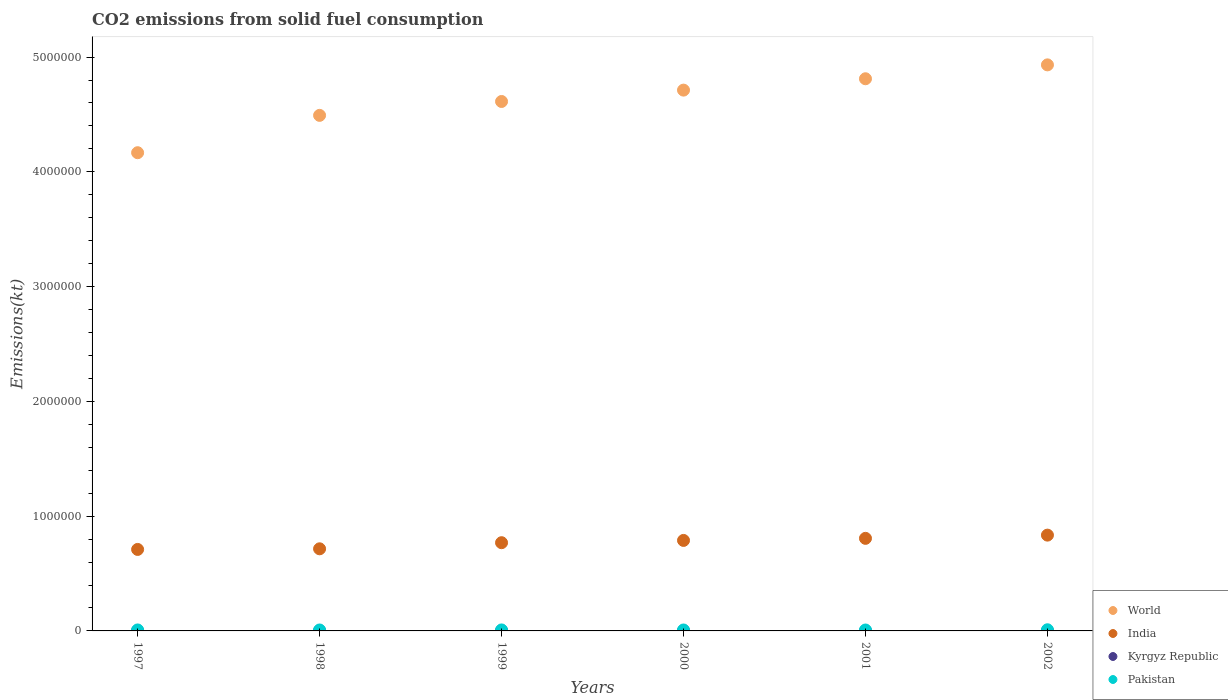What is the amount of CO2 emitted in World in 2000?
Your answer should be very brief. 4.71e+06. Across all years, what is the maximum amount of CO2 emitted in Pakistan?
Make the answer very short. 1.01e+04. Across all years, what is the minimum amount of CO2 emitted in Pakistan?
Your response must be concise. 8049.06. What is the total amount of CO2 emitted in India in the graph?
Offer a very short reply. 4.62e+06. What is the difference between the amount of CO2 emitted in Kyrgyz Republic in 1998 and that in 2000?
Offer a terse response. 51.34. What is the difference between the amount of CO2 emitted in Pakistan in 2000 and the amount of CO2 emitted in World in 2001?
Your answer should be compact. -4.80e+06. What is the average amount of CO2 emitted in World per year?
Offer a very short reply. 4.62e+06. In the year 1999, what is the difference between the amount of CO2 emitted in Pakistan and amount of CO2 emitted in World?
Keep it short and to the point. -4.60e+06. In how many years, is the amount of CO2 emitted in Pakistan greater than 4800000 kt?
Provide a succinct answer. 0. What is the ratio of the amount of CO2 emitted in Kyrgyz Republic in 2000 to that in 2001?
Keep it short and to the point. 1.58. Is the amount of CO2 emitted in Pakistan in 1997 less than that in 2001?
Your answer should be very brief. No. Is the difference between the amount of CO2 emitted in Pakistan in 1998 and 2001 greater than the difference between the amount of CO2 emitted in World in 1998 and 2001?
Make the answer very short. Yes. What is the difference between the highest and the second highest amount of CO2 emitted in India?
Give a very brief answer. 2.81e+04. What is the difference between the highest and the lowest amount of CO2 emitted in World?
Offer a terse response. 7.65e+05. In how many years, is the amount of CO2 emitted in Kyrgyz Republic greater than the average amount of CO2 emitted in Kyrgyz Republic taken over all years?
Provide a succinct answer. 5. Is it the case that in every year, the sum of the amount of CO2 emitted in World and amount of CO2 emitted in Kyrgyz Republic  is greater than the sum of amount of CO2 emitted in India and amount of CO2 emitted in Pakistan?
Your answer should be very brief. No. Does the amount of CO2 emitted in World monotonically increase over the years?
Your answer should be compact. Yes. Is the amount of CO2 emitted in Pakistan strictly greater than the amount of CO2 emitted in India over the years?
Provide a short and direct response. No. How many dotlines are there?
Keep it short and to the point. 4. What is the difference between two consecutive major ticks on the Y-axis?
Give a very brief answer. 1.00e+06. Are the values on the major ticks of Y-axis written in scientific E-notation?
Offer a terse response. No. Does the graph contain any zero values?
Ensure brevity in your answer.  No. Does the graph contain grids?
Your response must be concise. No. How many legend labels are there?
Your response must be concise. 4. How are the legend labels stacked?
Your answer should be very brief. Vertical. What is the title of the graph?
Your answer should be very brief. CO2 emissions from solid fuel consumption. Does "Sub-Saharan Africa (all income levels)" appear as one of the legend labels in the graph?
Offer a very short reply. No. What is the label or title of the Y-axis?
Provide a short and direct response. Emissions(kt). What is the Emissions(kt) in World in 1997?
Your response must be concise. 4.17e+06. What is the Emissions(kt) of India in 1997?
Offer a terse response. 7.10e+05. What is the Emissions(kt) of Kyrgyz Republic in 1997?
Offer a terse response. 1815.16. What is the Emissions(kt) in Pakistan in 1997?
Your answer should be very brief. 8580.78. What is the Emissions(kt) of World in 1998?
Your answer should be compact. 4.49e+06. What is the Emissions(kt) of India in 1998?
Provide a short and direct response. 7.15e+05. What is the Emissions(kt) in Kyrgyz Republic in 1998?
Your answer should be very brief. 1811.5. What is the Emissions(kt) of Pakistan in 1998?
Make the answer very short. 8188.41. What is the Emissions(kt) in World in 1999?
Provide a succinct answer. 4.61e+06. What is the Emissions(kt) in India in 1999?
Ensure brevity in your answer.  7.69e+05. What is the Emissions(kt) in Kyrgyz Republic in 1999?
Ensure brevity in your answer.  1807.83. What is the Emissions(kt) in Pakistan in 1999?
Provide a short and direct response. 8599.11. What is the Emissions(kt) in World in 2000?
Your answer should be compact. 4.71e+06. What is the Emissions(kt) in India in 2000?
Your response must be concise. 7.89e+05. What is the Emissions(kt) of Kyrgyz Republic in 2000?
Offer a very short reply. 1760.16. What is the Emissions(kt) in Pakistan in 2000?
Provide a succinct answer. 8195.75. What is the Emissions(kt) in World in 2001?
Provide a short and direct response. 4.81e+06. What is the Emissions(kt) of India in 2001?
Provide a short and direct response. 8.07e+05. What is the Emissions(kt) of Kyrgyz Republic in 2001?
Give a very brief answer. 1114.77. What is the Emissions(kt) in Pakistan in 2001?
Your answer should be compact. 8049.06. What is the Emissions(kt) of World in 2002?
Keep it short and to the point. 4.93e+06. What is the Emissions(kt) of India in 2002?
Give a very brief answer. 8.35e+05. What is the Emissions(kt) of Kyrgyz Republic in 2002?
Ensure brevity in your answer.  1877.5. What is the Emissions(kt) of Pakistan in 2002?
Your answer should be very brief. 1.01e+04. Across all years, what is the maximum Emissions(kt) in World?
Make the answer very short. 4.93e+06. Across all years, what is the maximum Emissions(kt) of India?
Your answer should be very brief. 8.35e+05. Across all years, what is the maximum Emissions(kt) of Kyrgyz Republic?
Give a very brief answer. 1877.5. Across all years, what is the maximum Emissions(kt) of Pakistan?
Keep it short and to the point. 1.01e+04. Across all years, what is the minimum Emissions(kt) of World?
Give a very brief answer. 4.17e+06. Across all years, what is the minimum Emissions(kt) of India?
Make the answer very short. 7.10e+05. Across all years, what is the minimum Emissions(kt) in Kyrgyz Republic?
Provide a short and direct response. 1114.77. Across all years, what is the minimum Emissions(kt) in Pakistan?
Provide a succinct answer. 8049.06. What is the total Emissions(kt) in World in the graph?
Offer a terse response. 2.77e+07. What is the total Emissions(kt) of India in the graph?
Give a very brief answer. 4.62e+06. What is the total Emissions(kt) of Kyrgyz Republic in the graph?
Provide a short and direct response. 1.02e+04. What is the total Emissions(kt) of Pakistan in the graph?
Offer a very short reply. 5.17e+04. What is the difference between the Emissions(kt) in World in 1997 and that in 1998?
Your response must be concise. -3.25e+05. What is the difference between the Emissions(kt) of India in 1997 and that in 1998?
Your response must be concise. -5460.16. What is the difference between the Emissions(kt) in Kyrgyz Republic in 1997 and that in 1998?
Make the answer very short. 3.67. What is the difference between the Emissions(kt) in Pakistan in 1997 and that in 1998?
Make the answer very short. 392.37. What is the difference between the Emissions(kt) in World in 1997 and that in 1999?
Your response must be concise. -4.46e+05. What is the difference between the Emissions(kt) of India in 1997 and that in 1999?
Offer a terse response. -5.87e+04. What is the difference between the Emissions(kt) of Kyrgyz Republic in 1997 and that in 1999?
Keep it short and to the point. 7.33. What is the difference between the Emissions(kt) of Pakistan in 1997 and that in 1999?
Offer a terse response. -18.34. What is the difference between the Emissions(kt) of World in 1997 and that in 2000?
Offer a very short reply. -5.45e+05. What is the difference between the Emissions(kt) of India in 1997 and that in 2000?
Your answer should be very brief. -7.85e+04. What is the difference between the Emissions(kt) of Kyrgyz Republic in 1997 and that in 2000?
Give a very brief answer. 55.01. What is the difference between the Emissions(kt) in Pakistan in 1997 and that in 2000?
Offer a very short reply. 385.04. What is the difference between the Emissions(kt) in World in 1997 and that in 2001?
Your response must be concise. -6.44e+05. What is the difference between the Emissions(kt) in India in 1997 and that in 2001?
Give a very brief answer. -9.66e+04. What is the difference between the Emissions(kt) in Kyrgyz Republic in 1997 and that in 2001?
Ensure brevity in your answer.  700.4. What is the difference between the Emissions(kt) in Pakistan in 1997 and that in 2001?
Keep it short and to the point. 531.72. What is the difference between the Emissions(kt) of World in 1997 and that in 2002?
Make the answer very short. -7.65e+05. What is the difference between the Emissions(kt) of India in 1997 and that in 2002?
Keep it short and to the point. -1.25e+05. What is the difference between the Emissions(kt) in Kyrgyz Republic in 1997 and that in 2002?
Offer a very short reply. -62.34. What is the difference between the Emissions(kt) in Pakistan in 1997 and that in 2002?
Make the answer very short. -1507.14. What is the difference between the Emissions(kt) of World in 1998 and that in 1999?
Make the answer very short. -1.21e+05. What is the difference between the Emissions(kt) in India in 1998 and that in 1999?
Your response must be concise. -5.32e+04. What is the difference between the Emissions(kt) in Kyrgyz Republic in 1998 and that in 1999?
Your answer should be compact. 3.67. What is the difference between the Emissions(kt) in Pakistan in 1998 and that in 1999?
Provide a short and direct response. -410.7. What is the difference between the Emissions(kt) of World in 1998 and that in 2000?
Your answer should be very brief. -2.20e+05. What is the difference between the Emissions(kt) in India in 1998 and that in 2000?
Offer a very short reply. -7.30e+04. What is the difference between the Emissions(kt) of Kyrgyz Republic in 1998 and that in 2000?
Your response must be concise. 51.34. What is the difference between the Emissions(kt) of Pakistan in 1998 and that in 2000?
Ensure brevity in your answer.  -7.33. What is the difference between the Emissions(kt) in World in 1998 and that in 2001?
Provide a short and direct response. -3.19e+05. What is the difference between the Emissions(kt) of India in 1998 and that in 2001?
Keep it short and to the point. -9.11e+04. What is the difference between the Emissions(kt) in Kyrgyz Republic in 1998 and that in 2001?
Make the answer very short. 696.73. What is the difference between the Emissions(kt) in Pakistan in 1998 and that in 2001?
Ensure brevity in your answer.  139.35. What is the difference between the Emissions(kt) in World in 1998 and that in 2002?
Your answer should be very brief. -4.40e+05. What is the difference between the Emissions(kt) in India in 1998 and that in 2002?
Your answer should be compact. -1.19e+05. What is the difference between the Emissions(kt) of Kyrgyz Republic in 1998 and that in 2002?
Your answer should be very brief. -66.01. What is the difference between the Emissions(kt) in Pakistan in 1998 and that in 2002?
Your response must be concise. -1899.51. What is the difference between the Emissions(kt) of World in 1999 and that in 2000?
Your response must be concise. -9.90e+04. What is the difference between the Emissions(kt) of India in 1999 and that in 2000?
Keep it short and to the point. -1.98e+04. What is the difference between the Emissions(kt) in Kyrgyz Republic in 1999 and that in 2000?
Offer a terse response. 47.67. What is the difference between the Emissions(kt) in Pakistan in 1999 and that in 2000?
Your response must be concise. 403.37. What is the difference between the Emissions(kt) of World in 1999 and that in 2001?
Your answer should be compact. -1.98e+05. What is the difference between the Emissions(kt) in India in 1999 and that in 2001?
Ensure brevity in your answer.  -3.79e+04. What is the difference between the Emissions(kt) in Kyrgyz Republic in 1999 and that in 2001?
Offer a very short reply. 693.06. What is the difference between the Emissions(kt) of Pakistan in 1999 and that in 2001?
Your response must be concise. 550.05. What is the difference between the Emissions(kt) of World in 1999 and that in 2002?
Your answer should be compact. -3.19e+05. What is the difference between the Emissions(kt) of India in 1999 and that in 2002?
Ensure brevity in your answer.  -6.60e+04. What is the difference between the Emissions(kt) of Kyrgyz Republic in 1999 and that in 2002?
Your response must be concise. -69.67. What is the difference between the Emissions(kt) in Pakistan in 1999 and that in 2002?
Your answer should be very brief. -1488.8. What is the difference between the Emissions(kt) in World in 2000 and that in 2001?
Your answer should be very brief. -9.90e+04. What is the difference between the Emissions(kt) in India in 2000 and that in 2001?
Provide a short and direct response. -1.81e+04. What is the difference between the Emissions(kt) in Kyrgyz Republic in 2000 and that in 2001?
Your answer should be very brief. 645.39. What is the difference between the Emissions(kt) of Pakistan in 2000 and that in 2001?
Provide a short and direct response. 146.68. What is the difference between the Emissions(kt) of World in 2000 and that in 2002?
Offer a very short reply. -2.20e+05. What is the difference between the Emissions(kt) of India in 2000 and that in 2002?
Provide a short and direct response. -4.62e+04. What is the difference between the Emissions(kt) in Kyrgyz Republic in 2000 and that in 2002?
Your answer should be very brief. -117.34. What is the difference between the Emissions(kt) of Pakistan in 2000 and that in 2002?
Make the answer very short. -1892.17. What is the difference between the Emissions(kt) of World in 2001 and that in 2002?
Your response must be concise. -1.21e+05. What is the difference between the Emissions(kt) of India in 2001 and that in 2002?
Your answer should be compact. -2.81e+04. What is the difference between the Emissions(kt) of Kyrgyz Republic in 2001 and that in 2002?
Your answer should be compact. -762.74. What is the difference between the Emissions(kt) of Pakistan in 2001 and that in 2002?
Make the answer very short. -2038.85. What is the difference between the Emissions(kt) in World in 1997 and the Emissions(kt) in India in 1998?
Your answer should be compact. 3.45e+06. What is the difference between the Emissions(kt) of World in 1997 and the Emissions(kt) of Kyrgyz Republic in 1998?
Give a very brief answer. 4.16e+06. What is the difference between the Emissions(kt) in World in 1997 and the Emissions(kt) in Pakistan in 1998?
Give a very brief answer. 4.16e+06. What is the difference between the Emissions(kt) in India in 1997 and the Emissions(kt) in Kyrgyz Republic in 1998?
Your answer should be compact. 7.08e+05. What is the difference between the Emissions(kt) in India in 1997 and the Emissions(kt) in Pakistan in 1998?
Ensure brevity in your answer.  7.02e+05. What is the difference between the Emissions(kt) in Kyrgyz Republic in 1997 and the Emissions(kt) in Pakistan in 1998?
Ensure brevity in your answer.  -6373.25. What is the difference between the Emissions(kt) in World in 1997 and the Emissions(kt) in India in 1999?
Keep it short and to the point. 3.40e+06. What is the difference between the Emissions(kt) of World in 1997 and the Emissions(kt) of Kyrgyz Republic in 1999?
Provide a succinct answer. 4.16e+06. What is the difference between the Emissions(kt) in World in 1997 and the Emissions(kt) in Pakistan in 1999?
Your answer should be very brief. 4.16e+06. What is the difference between the Emissions(kt) in India in 1997 and the Emissions(kt) in Kyrgyz Republic in 1999?
Provide a short and direct response. 7.08e+05. What is the difference between the Emissions(kt) in India in 1997 and the Emissions(kt) in Pakistan in 1999?
Your response must be concise. 7.01e+05. What is the difference between the Emissions(kt) in Kyrgyz Republic in 1997 and the Emissions(kt) in Pakistan in 1999?
Make the answer very short. -6783.95. What is the difference between the Emissions(kt) of World in 1997 and the Emissions(kt) of India in 2000?
Your answer should be compact. 3.38e+06. What is the difference between the Emissions(kt) of World in 1997 and the Emissions(kt) of Kyrgyz Republic in 2000?
Make the answer very short. 4.17e+06. What is the difference between the Emissions(kt) in World in 1997 and the Emissions(kt) in Pakistan in 2000?
Ensure brevity in your answer.  4.16e+06. What is the difference between the Emissions(kt) of India in 1997 and the Emissions(kt) of Kyrgyz Republic in 2000?
Make the answer very short. 7.08e+05. What is the difference between the Emissions(kt) of India in 1997 and the Emissions(kt) of Pakistan in 2000?
Your response must be concise. 7.02e+05. What is the difference between the Emissions(kt) in Kyrgyz Republic in 1997 and the Emissions(kt) in Pakistan in 2000?
Offer a very short reply. -6380.58. What is the difference between the Emissions(kt) of World in 1997 and the Emissions(kt) of India in 2001?
Make the answer very short. 3.36e+06. What is the difference between the Emissions(kt) of World in 1997 and the Emissions(kt) of Kyrgyz Republic in 2001?
Give a very brief answer. 4.17e+06. What is the difference between the Emissions(kt) in World in 1997 and the Emissions(kt) in Pakistan in 2001?
Provide a succinct answer. 4.16e+06. What is the difference between the Emissions(kt) in India in 1997 and the Emissions(kt) in Kyrgyz Republic in 2001?
Your answer should be compact. 7.09e+05. What is the difference between the Emissions(kt) of India in 1997 and the Emissions(kt) of Pakistan in 2001?
Offer a very short reply. 7.02e+05. What is the difference between the Emissions(kt) in Kyrgyz Republic in 1997 and the Emissions(kt) in Pakistan in 2001?
Provide a succinct answer. -6233.9. What is the difference between the Emissions(kt) of World in 1997 and the Emissions(kt) of India in 2002?
Provide a succinct answer. 3.33e+06. What is the difference between the Emissions(kt) in World in 1997 and the Emissions(kt) in Kyrgyz Republic in 2002?
Provide a short and direct response. 4.16e+06. What is the difference between the Emissions(kt) in World in 1997 and the Emissions(kt) in Pakistan in 2002?
Provide a succinct answer. 4.16e+06. What is the difference between the Emissions(kt) in India in 1997 and the Emissions(kt) in Kyrgyz Republic in 2002?
Give a very brief answer. 7.08e+05. What is the difference between the Emissions(kt) of India in 1997 and the Emissions(kt) of Pakistan in 2002?
Provide a succinct answer. 7.00e+05. What is the difference between the Emissions(kt) in Kyrgyz Republic in 1997 and the Emissions(kt) in Pakistan in 2002?
Ensure brevity in your answer.  -8272.75. What is the difference between the Emissions(kt) in World in 1998 and the Emissions(kt) in India in 1999?
Your answer should be very brief. 3.72e+06. What is the difference between the Emissions(kt) of World in 1998 and the Emissions(kt) of Kyrgyz Republic in 1999?
Offer a very short reply. 4.49e+06. What is the difference between the Emissions(kt) of World in 1998 and the Emissions(kt) of Pakistan in 1999?
Provide a succinct answer. 4.48e+06. What is the difference between the Emissions(kt) of India in 1998 and the Emissions(kt) of Kyrgyz Republic in 1999?
Your answer should be compact. 7.14e+05. What is the difference between the Emissions(kt) of India in 1998 and the Emissions(kt) of Pakistan in 1999?
Your response must be concise. 7.07e+05. What is the difference between the Emissions(kt) of Kyrgyz Republic in 1998 and the Emissions(kt) of Pakistan in 1999?
Make the answer very short. -6787.62. What is the difference between the Emissions(kt) of World in 1998 and the Emissions(kt) of India in 2000?
Provide a short and direct response. 3.70e+06. What is the difference between the Emissions(kt) of World in 1998 and the Emissions(kt) of Kyrgyz Republic in 2000?
Give a very brief answer. 4.49e+06. What is the difference between the Emissions(kt) in World in 1998 and the Emissions(kt) in Pakistan in 2000?
Provide a short and direct response. 4.48e+06. What is the difference between the Emissions(kt) in India in 1998 and the Emissions(kt) in Kyrgyz Republic in 2000?
Your answer should be very brief. 7.14e+05. What is the difference between the Emissions(kt) in India in 1998 and the Emissions(kt) in Pakistan in 2000?
Offer a terse response. 7.07e+05. What is the difference between the Emissions(kt) of Kyrgyz Republic in 1998 and the Emissions(kt) of Pakistan in 2000?
Your answer should be compact. -6384.25. What is the difference between the Emissions(kt) in World in 1998 and the Emissions(kt) in India in 2001?
Ensure brevity in your answer.  3.69e+06. What is the difference between the Emissions(kt) of World in 1998 and the Emissions(kt) of Kyrgyz Republic in 2001?
Provide a succinct answer. 4.49e+06. What is the difference between the Emissions(kt) in World in 1998 and the Emissions(kt) in Pakistan in 2001?
Offer a very short reply. 4.48e+06. What is the difference between the Emissions(kt) in India in 1998 and the Emissions(kt) in Kyrgyz Republic in 2001?
Provide a short and direct response. 7.14e+05. What is the difference between the Emissions(kt) of India in 1998 and the Emissions(kt) of Pakistan in 2001?
Give a very brief answer. 7.07e+05. What is the difference between the Emissions(kt) of Kyrgyz Republic in 1998 and the Emissions(kt) of Pakistan in 2001?
Make the answer very short. -6237.57. What is the difference between the Emissions(kt) of World in 1998 and the Emissions(kt) of India in 2002?
Your answer should be compact. 3.66e+06. What is the difference between the Emissions(kt) in World in 1998 and the Emissions(kt) in Kyrgyz Republic in 2002?
Offer a very short reply. 4.49e+06. What is the difference between the Emissions(kt) in World in 1998 and the Emissions(kt) in Pakistan in 2002?
Give a very brief answer. 4.48e+06. What is the difference between the Emissions(kt) in India in 1998 and the Emissions(kt) in Kyrgyz Republic in 2002?
Provide a short and direct response. 7.14e+05. What is the difference between the Emissions(kt) of India in 1998 and the Emissions(kt) of Pakistan in 2002?
Provide a short and direct response. 7.05e+05. What is the difference between the Emissions(kt) of Kyrgyz Republic in 1998 and the Emissions(kt) of Pakistan in 2002?
Offer a terse response. -8276.42. What is the difference between the Emissions(kt) in World in 1999 and the Emissions(kt) in India in 2000?
Offer a very short reply. 3.82e+06. What is the difference between the Emissions(kt) of World in 1999 and the Emissions(kt) of Kyrgyz Republic in 2000?
Your answer should be very brief. 4.61e+06. What is the difference between the Emissions(kt) in World in 1999 and the Emissions(kt) in Pakistan in 2000?
Give a very brief answer. 4.60e+06. What is the difference between the Emissions(kt) in India in 1999 and the Emissions(kt) in Kyrgyz Republic in 2000?
Ensure brevity in your answer.  7.67e+05. What is the difference between the Emissions(kt) of India in 1999 and the Emissions(kt) of Pakistan in 2000?
Provide a succinct answer. 7.60e+05. What is the difference between the Emissions(kt) of Kyrgyz Republic in 1999 and the Emissions(kt) of Pakistan in 2000?
Provide a succinct answer. -6387.91. What is the difference between the Emissions(kt) in World in 1999 and the Emissions(kt) in India in 2001?
Provide a succinct answer. 3.81e+06. What is the difference between the Emissions(kt) in World in 1999 and the Emissions(kt) in Kyrgyz Republic in 2001?
Ensure brevity in your answer.  4.61e+06. What is the difference between the Emissions(kt) in World in 1999 and the Emissions(kt) in Pakistan in 2001?
Your response must be concise. 4.61e+06. What is the difference between the Emissions(kt) of India in 1999 and the Emissions(kt) of Kyrgyz Republic in 2001?
Your response must be concise. 7.68e+05. What is the difference between the Emissions(kt) in India in 1999 and the Emissions(kt) in Pakistan in 2001?
Offer a terse response. 7.61e+05. What is the difference between the Emissions(kt) of Kyrgyz Republic in 1999 and the Emissions(kt) of Pakistan in 2001?
Provide a succinct answer. -6241.23. What is the difference between the Emissions(kt) of World in 1999 and the Emissions(kt) of India in 2002?
Make the answer very short. 3.78e+06. What is the difference between the Emissions(kt) in World in 1999 and the Emissions(kt) in Kyrgyz Republic in 2002?
Offer a terse response. 4.61e+06. What is the difference between the Emissions(kt) in World in 1999 and the Emissions(kt) in Pakistan in 2002?
Your response must be concise. 4.60e+06. What is the difference between the Emissions(kt) in India in 1999 and the Emissions(kt) in Kyrgyz Republic in 2002?
Offer a terse response. 7.67e+05. What is the difference between the Emissions(kt) of India in 1999 and the Emissions(kt) of Pakistan in 2002?
Your answer should be very brief. 7.59e+05. What is the difference between the Emissions(kt) of Kyrgyz Republic in 1999 and the Emissions(kt) of Pakistan in 2002?
Your response must be concise. -8280.09. What is the difference between the Emissions(kt) in World in 2000 and the Emissions(kt) in India in 2001?
Give a very brief answer. 3.91e+06. What is the difference between the Emissions(kt) in World in 2000 and the Emissions(kt) in Kyrgyz Republic in 2001?
Provide a succinct answer. 4.71e+06. What is the difference between the Emissions(kt) of World in 2000 and the Emissions(kt) of Pakistan in 2001?
Your answer should be very brief. 4.70e+06. What is the difference between the Emissions(kt) of India in 2000 and the Emissions(kt) of Kyrgyz Republic in 2001?
Offer a terse response. 7.87e+05. What is the difference between the Emissions(kt) of India in 2000 and the Emissions(kt) of Pakistan in 2001?
Provide a short and direct response. 7.80e+05. What is the difference between the Emissions(kt) of Kyrgyz Republic in 2000 and the Emissions(kt) of Pakistan in 2001?
Ensure brevity in your answer.  -6288.9. What is the difference between the Emissions(kt) of World in 2000 and the Emissions(kt) of India in 2002?
Provide a succinct answer. 3.88e+06. What is the difference between the Emissions(kt) of World in 2000 and the Emissions(kt) of Kyrgyz Republic in 2002?
Ensure brevity in your answer.  4.71e+06. What is the difference between the Emissions(kt) of World in 2000 and the Emissions(kt) of Pakistan in 2002?
Give a very brief answer. 4.70e+06. What is the difference between the Emissions(kt) in India in 2000 and the Emissions(kt) in Kyrgyz Republic in 2002?
Ensure brevity in your answer.  7.87e+05. What is the difference between the Emissions(kt) of India in 2000 and the Emissions(kt) of Pakistan in 2002?
Give a very brief answer. 7.78e+05. What is the difference between the Emissions(kt) of Kyrgyz Republic in 2000 and the Emissions(kt) of Pakistan in 2002?
Give a very brief answer. -8327.76. What is the difference between the Emissions(kt) in World in 2001 and the Emissions(kt) in India in 2002?
Your answer should be very brief. 3.98e+06. What is the difference between the Emissions(kt) of World in 2001 and the Emissions(kt) of Kyrgyz Republic in 2002?
Your answer should be compact. 4.81e+06. What is the difference between the Emissions(kt) in World in 2001 and the Emissions(kt) in Pakistan in 2002?
Make the answer very short. 4.80e+06. What is the difference between the Emissions(kt) of India in 2001 and the Emissions(kt) of Kyrgyz Republic in 2002?
Offer a very short reply. 8.05e+05. What is the difference between the Emissions(kt) in India in 2001 and the Emissions(kt) in Pakistan in 2002?
Offer a very short reply. 7.96e+05. What is the difference between the Emissions(kt) in Kyrgyz Republic in 2001 and the Emissions(kt) in Pakistan in 2002?
Offer a very short reply. -8973.15. What is the average Emissions(kt) of World per year?
Give a very brief answer. 4.62e+06. What is the average Emissions(kt) of India per year?
Provide a succinct answer. 7.71e+05. What is the average Emissions(kt) of Kyrgyz Republic per year?
Provide a succinct answer. 1697.82. What is the average Emissions(kt) of Pakistan per year?
Keep it short and to the point. 8616.84. In the year 1997, what is the difference between the Emissions(kt) in World and Emissions(kt) in India?
Offer a terse response. 3.46e+06. In the year 1997, what is the difference between the Emissions(kt) in World and Emissions(kt) in Kyrgyz Republic?
Provide a succinct answer. 4.16e+06. In the year 1997, what is the difference between the Emissions(kt) in World and Emissions(kt) in Pakistan?
Offer a terse response. 4.16e+06. In the year 1997, what is the difference between the Emissions(kt) of India and Emissions(kt) of Kyrgyz Republic?
Provide a short and direct response. 7.08e+05. In the year 1997, what is the difference between the Emissions(kt) of India and Emissions(kt) of Pakistan?
Offer a very short reply. 7.01e+05. In the year 1997, what is the difference between the Emissions(kt) in Kyrgyz Republic and Emissions(kt) in Pakistan?
Your response must be concise. -6765.61. In the year 1998, what is the difference between the Emissions(kt) in World and Emissions(kt) in India?
Provide a succinct answer. 3.78e+06. In the year 1998, what is the difference between the Emissions(kt) in World and Emissions(kt) in Kyrgyz Republic?
Your answer should be very brief. 4.49e+06. In the year 1998, what is the difference between the Emissions(kt) in World and Emissions(kt) in Pakistan?
Provide a succinct answer. 4.48e+06. In the year 1998, what is the difference between the Emissions(kt) of India and Emissions(kt) of Kyrgyz Republic?
Provide a short and direct response. 7.14e+05. In the year 1998, what is the difference between the Emissions(kt) in India and Emissions(kt) in Pakistan?
Make the answer very short. 7.07e+05. In the year 1998, what is the difference between the Emissions(kt) of Kyrgyz Republic and Emissions(kt) of Pakistan?
Your answer should be very brief. -6376.91. In the year 1999, what is the difference between the Emissions(kt) in World and Emissions(kt) in India?
Your response must be concise. 3.84e+06. In the year 1999, what is the difference between the Emissions(kt) of World and Emissions(kt) of Kyrgyz Republic?
Your answer should be very brief. 4.61e+06. In the year 1999, what is the difference between the Emissions(kt) of World and Emissions(kt) of Pakistan?
Your answer should be very brief. 4.60e+06. In the year 1999, what is the difference between the Emissions(kt) in India and Emissions(kt) in Kyrgyz Republic?
Provide a short and direct response. 7.67e+05. In the year 1999, what is the difference between the Emissions(kt) in India and Emissions(kt) in Pakistan?
Keep it short and to the point. 7.60e+05. In the year 1999, what is the difference between the Emissions(kt) of Kyrgyz Republic and Emissions(kt) of Pakistan?
Keep it short and to the point. -6791.28. In the year 2000, what is the difference between the Emissions(kt) of World and Emissions(kt) of India?
Ensure brevity in your answer.  3.92e+06. In the year 2000, what is the difference between the Emissions(kt) of World and Emissions(kt) of Kyrgyz Republic?
Make the answer very short. 4.71e+06. In the year 2000, what is the difference between the Emissions(kt) in World and Emissions(kt) in Pakistan?
Offer a terse response. 4.70e+06. In the year 2000, what is the difference between the Emissions(kt) in India and Emissions(kt) in Kyrgyz Republic?
Provide a short and direct response. 7.87e+05. In the year 2000, what is the difference between the Emissions(kt) in India and Emissions(kt) in Pakistan?
Keep it short and to the point. 7.80e+05. In the year 2000, what is the difference between the Emissions(kt) of Kyrgyz Republic and Emissions(kt) of Pakistan?
Offer a very short reply. -6435.59. In the year 2001, what is the difference between the Emissions(kt) of World and Emissions(kt) of India?
Your response must be concise. 4.00e+06. In the year 2001, what is the difference between the Emissions(kt) of World and Emissions(kt) of Kyrgyz Republic?
Your response must be concise. 4.81e+06. In the year 2001, what is the difference between the Emissions(kt) of World and Emissions(kt) of Pakistan?
Keep it short and to the point. 4.80e+06. In the year 2001, what is the difference between the Emissions(kt) in India and Emissions(kt) in Kyrgyz Republic?
Provide a succinct answer. 8.05e+05. In the year 2001, what is the difference between the Emissions(kt) of India and Emissions(kt) of Pakistan?
Give a very brief answer. 7.99e+05. In the year 2001, what is the difference between the Emissions(kt) of Kyrgyz Republic and Emissions(kt) of Pakistan?
Offer a very short reply. -6934.3. In the year 2002, what is the difference between the Emissions(kt) in World and Emissions(kt) in India?
Provide a short and direct response. 4.10e+06. In the year 2002, what is the difference between the Emissions(kt) in World and Emissions(kt) in Kyrgyz Republic?
Give a very brief answer. 4.93e+06. In the year 2002, what is the difference between the Emissions(kt) of World and Emissions(kt) of Pakistan?
Make the answer very short. 4.92e+06. In the year 2002, what is the difference between the Emissions(kt) of India and Emissions(kt) of Kyrgyz Republic?
Offer a terse response. 8.33e+05. In the year 2002, what is the difference between the Emissions(kt) of India and Emissions(kt) of Pakistan?
Your response must be concise. 8.25e+05. In the year 2002, what is the difference between the Emissions(kt) of Kyrgyz Republic and Emissions(kt) of Pakistan?
Your answer should be compact. -8210.41. What is the ratio of the Emissions(kt) in World in 1997 to that in 1998?
Provide a succinct answer. 0.93. What is the ratio of the Emissions(kt) in India in 1997 to that in 1998?
Keep it short and to the point. 0.99. What is the ratio of the Emissions(kt) in Kyrgyz Republic in 1997 to that in 1998?
Make the answer very short. 1. What is the ratio of the Emissions(kt) of Pakistan in 1997 to that in 1998?
Keep it short and to the point. 1.05. What is the ratio of the Emissions(kt) in World in 1997 to that in 1999?
Give a very brief answer. 0.9. What is the ratio of the Emissions(kt) of India in 1997 to that in 1999?
Give a very brief answer. 0.92. What is the ratio of the Emissions(kt) of Pakistan in 1997 to that in 1999?
Make the answer very short. 1. What is the ratio of the Emissions(kt) in World in 1997 to that in 2000?
Offer a very short reply. 0.88. What is the ratio of the Emissions(kt) in India in 1997 to that in 2000?
Offer a very short reply. 0.9. What is the ratio of the Emissions(kt) of Kyrgyz Republic in 1997 to that in 2000?
Make the answer very short. 1.03. What is the ratio of the Emissions(kt) in Pakistan in 1997 to that in 2000?
Offer a very short reply. 1.05. What is the ratio of the Emissions(kt) in World in 1997 to that in 2001?
Your answer should be compact. 0.87. What is the ratio of the Emissions(kt) in India in 1997 to that in 2001?
Provide a short and direct response. 0.88. What is the ratio of the Emissions(kt) of Kyrgyz Republic in 1997 to that in 2001?
Make the answer very short. 1.63. What is the ratio of the Emissions(kt) of Pakistan in 1997 to that in 2001?
Provide a succinct answer. 1.07. What is the ratio of the Emissions(kt) in World in 1997 to that in 2002?
Offer a terse response. 0.84. What is the ratio of the Emissions(kt) of India in 1997 to that in 2002?
Give a very brief answer. 0.85. What is the ratio of the Emissions(kt) of Kyrgyz Republic in 1997 to that in 2002?
Make the answer very short. 0.97. What is the ratio of the Emissions(kt) in Pakistan in 1997 to that in 2002?
Make the answer very short. 0.85. What is the ratio of the Emissions(kt) in World in 1998 to that in 1999?
Your answer should be compact. 0.97. What is the ratio of the Emissions(kt) of India in 1998 to that in 1999?
Give a very brief answer. 0.93. What is the ratio of the Emissions(kt) of Kyrgyz Republic in 1998 to that in 1999?
Offer a very short reply. 1. What is the ratio of the Emissions(kt) of Pakistan in 1998 to that in 1999?
Provide a short and direct response. 0.95. What is the ratio of the Emissions(kt) of World in 1998 to that in 2000?
Offer a terse response. 0.95. What is the ratio of the Emissions(kt) in India in 1998 to that in 2000?
Offer a very short reply. 0.91. What is the ratio of the Emissions(kt) in Kyrgyz Republic in 1998 to that in 2000?
Your response must be concise. 1.03. What is the ratio of the Emissions(kt) of World in 1998 to that in 2001?
Make the answer very short. 0.93. What is the ratio of the Emissions(kt) in India in 1998 to that in 2001?
Your answer should be compact. 0.89. What is the ratio of the Emissions(kt) in Kyrgyz Republic in 1998 to that in 2001?
Provide a succinct answer. 1.62. What is the ratio of the Emissions(kt) of Pakistan in 1998 to that in 2001?
Keep it short and to the point. 1.02. What is the ratio of the Emissions(kt) in World in 1998 to that in 2002?
Offer a terse response. 0.91. What is the ratio of the Emissions(kt) of India in 1998 to that in 2002?
Your answer should be compact. 0.86. What is the ratio of the Emissions(kt) of Kyrgyz Republic in 1998 to that in 2002?
Make the answer very short. 0.96. What is the ratio of the Emissions(kt) of Pakistan in 1998 to that in 2002?
Offer a terse response. 0.81. What is the ratio of the Emissions(kt) in World in 1999 to that in 2000?
Provide a short and direct response. 0.98. What is the ratio of the Emissions(kt) in India in 1999 to that in 2000?
Keep it short and to the point. 0.97. What is the ratio of the Emissions(kt) in Kyrgyz Republic in 1999 to that in 2000?
Keep it short and to the point. 1.03. What is the ratio of the Emissions(kt) in Pakistan in 1999 to that in 2000?
Provide a short and direct response. 1.05. What is the ratio of the Emissions(kt) in World in 1999 to that in 2001?
Offer a very short reply. 0.96. What is the ratio of the Emissions(kt) of India in 1999 to that in 2001?
Offer a very short reply. 0.95. What is the ratio of the Emissions(kt) in Kyrgyz Republic in 1999 to that in 2001?
Your response must be concise. 1.62. What is the ratio of the Emissions(kt) of Pakistan in 1999 to that in 2001?
Your answer should be very brief. 1.07. What is the ratio of the Emissions(kt) in World in 1999 to that in 2002?
Keep it short and to the point. 0.94. What is the ratio of the Emissions(kt) of India in 1999 to that in 2002?
Offer a terse response. 0.92. What is the ratio of the Emissions(kt) of Kyrgyz Republic in 1999 to that in 2002?
Make the answer very short. 0.96. What is the ratio of the Emissions(kt) of Pakistan in 1999 to that in 2002?
Provide a short and direct response. 0.85. What is the ratio of the Emissions(kt) of World in 2000 to that in 2001?
Your answer should be very brief. 0.98. What is the ratio of the Emissions(kt) in India in 2000 to that in 2001?
Give a very brief answer. 0.98. What is the ratio of the Emissions(kt) in Kyrgyz Republic in 2000 to that in 2001?
Offer a terse response. 1.58. What is the ratio of the Emissions(kt) of Pakistan in 2000 to that in 2001?
Ensure brevity in your answer.  1.02. What is the ratio of the Emissions(kt) of World in 2000 to that in 2002?
Make the answer very short. 0.96. What is the ratio of the Emissions(kt) in India in 2000 to that in 2002?
Provide a short and direct response. 0.94. What is the ratio of the Emissions(kt) in Pakistan in 2000 to that in 2002?
Ensure brevity in your answer.  0.81. What is the ratio of the Emissions(kt) of World in 2001 to that in 2002?
Provide a succinct answer. 0.98. What is the ratio of the Emissions(kt) of India in 2001 to that in 2002?
Provide a short and direct response. 0.97. What is the ratio of the Emissions(kt) in Kyrgyz Republic in 2001 to that in 2002?
Your response must be concise. 0.59. What is the ratio of the Emissions(kt) of Pakistan in 2001 to that in 2002?
Make the answer very short. 0.8. What is the difference between the highest and the second highest Emissions(kt) in World?
Give a very brief answer. 1.21e+05. What is the difference between the highest and the second highest Emissions(kt) in India?
Provide a short and direct response. 2.81e+04. What is the difference between the highest and the second highest Emissions(kt) of Kyrgyz Republic?
Give a very brief answer. 62.34. What is the difference between the highest and the second highest Emissions(kt) of Pakistan?
Give a very brief answer. 1488.8. What is the difference between the highest and the lowest Emissions(kt) in World?
Make the answer very short. 7.65e+05. What is the difference between the highest and the lowest Emissions(kt) in India?
Give a very brief answer. 1.25e+05. What is the difference between the highest and the lowest Emissions(kt) in Kyrgyz Republic?
Your response must be concise. 762.74. What is the difference between the highest and the lowest Emissions(kt) of Pakistan?
Give a very brief answer. 2038.85. 